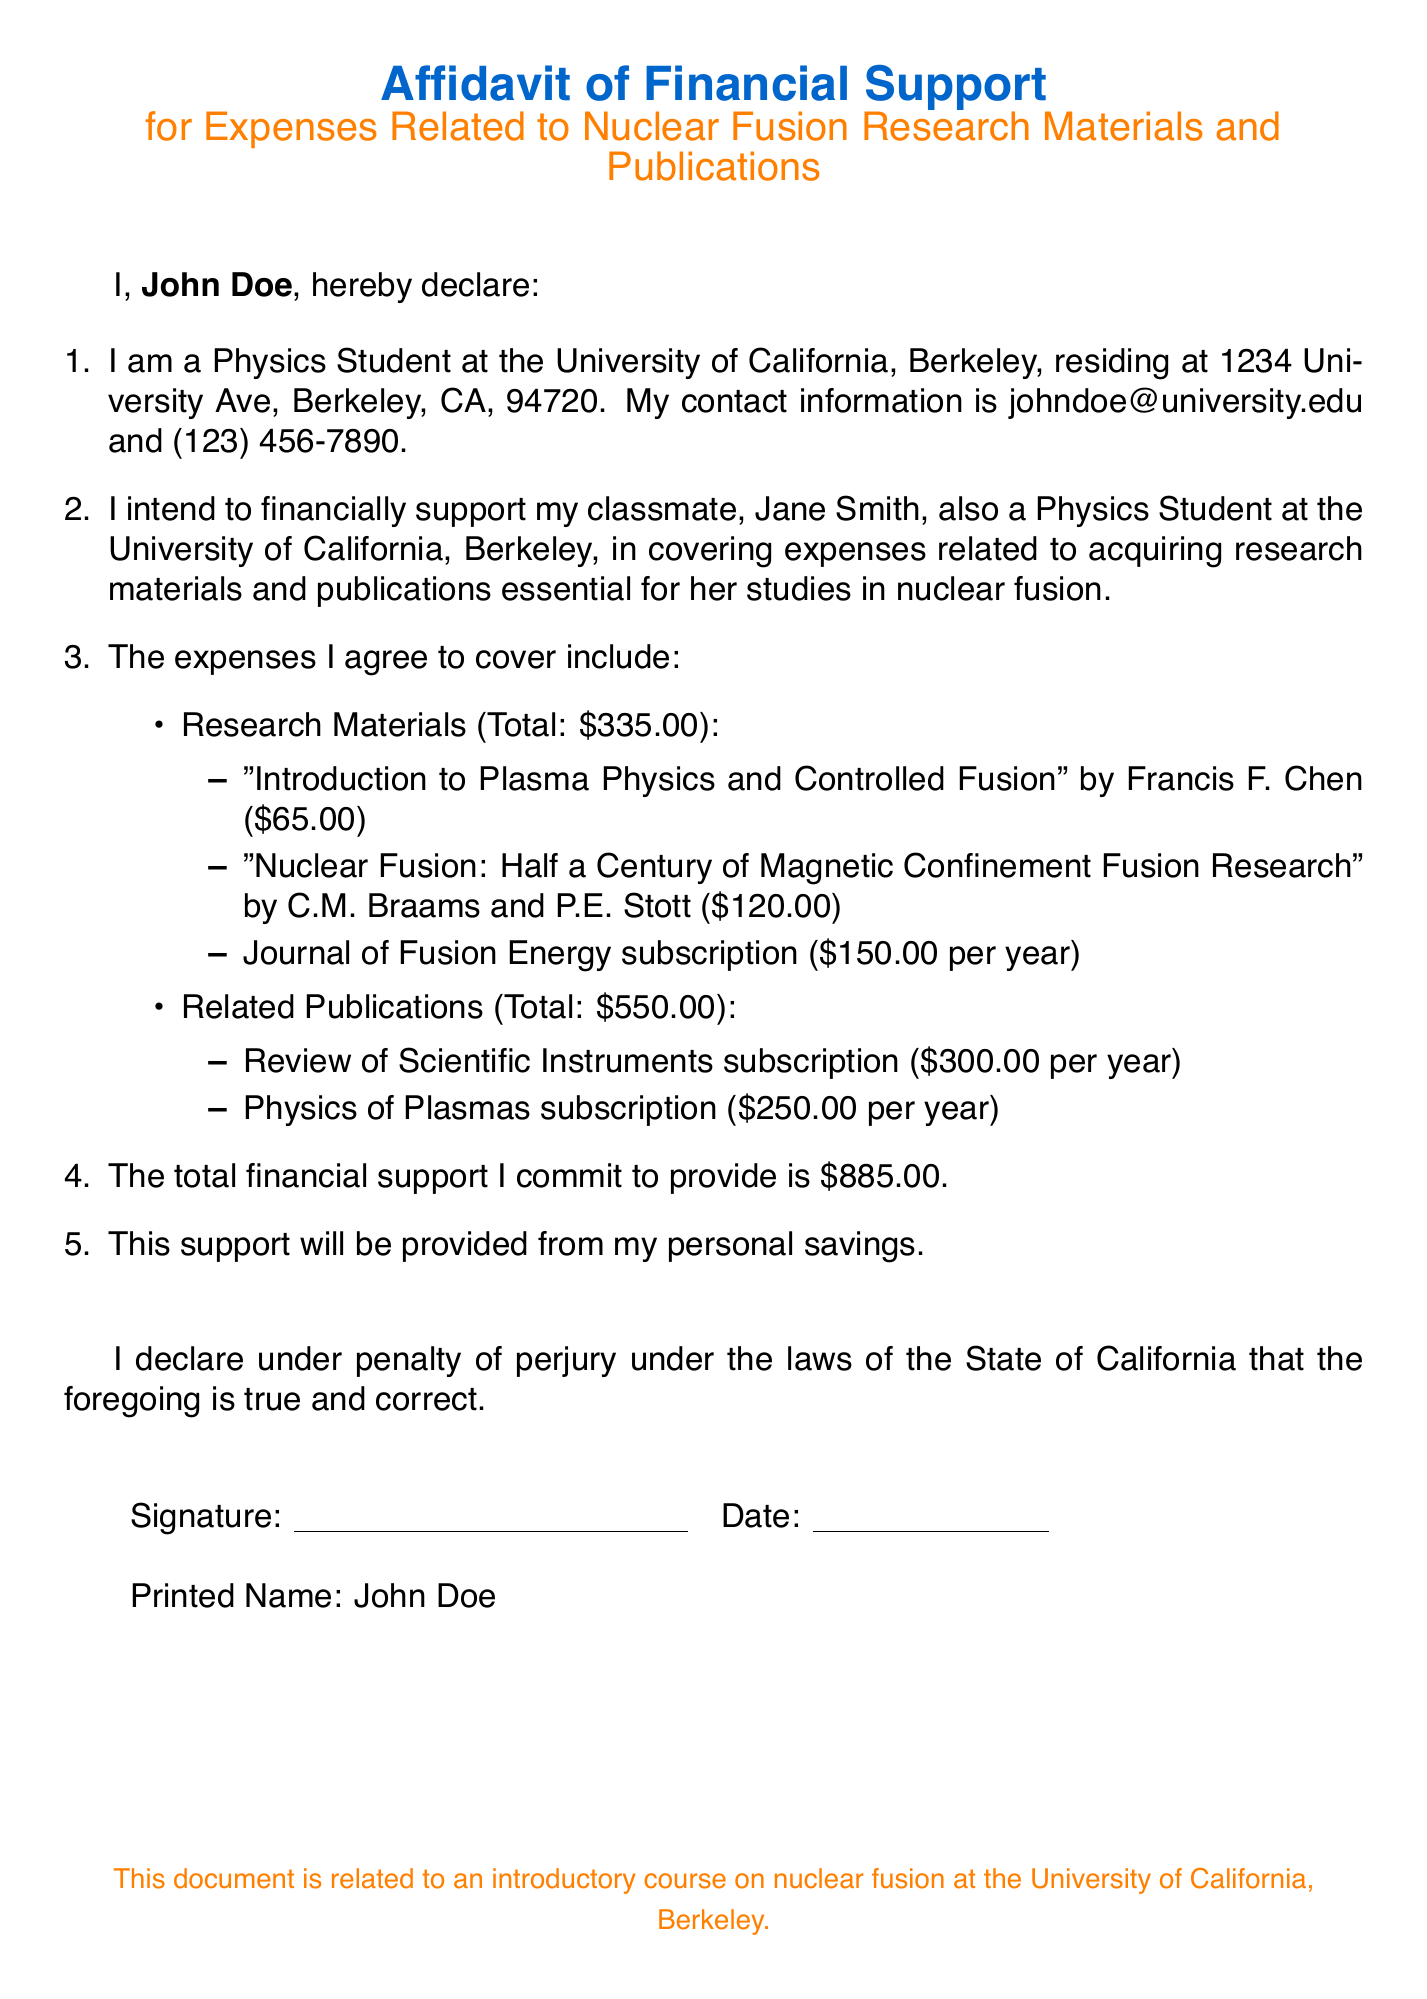What is the name of the affiant? The affiant is the person making the declaration in the affidavit, which is John Doe.
Answer: John Doe What is Jane Smith’s relationship to the affiant? Jane Smith is the classmate of the affiant, and the affiant intends to financially support her.
Answer: Classmate What is the total amount the affiant commits to provide? The total financial support can be found in the document, which specifies that the amount is eight hundred eighty-five dollars.
Answer: $885.00 How much does the subscription to the Journal of Fusion Energy cost? The document lists the cost of the Journal of Fusion Energy subscription as one hundred fifty dollars per year.
Answer: $150.00 From what sources will the financial support be provided? The document states that the support will be provided from the affiant's personal savings.
Answer: Personal savings What is the address of the affiant? The address is mentioned in the document as 1234 University Ave, Berkeley, CA, 94720.
Answer: 1234 University Ave, Berkeley, CA, 94720 What is the total cost for research materials? The total cost for research materials is specified in the document as three hundred thirty-five dollars.
Answer: $335.00 What type of document is this? It specifies in the header as an affidavit of financial support for research materials and publications.
Answer: Affidavit How many subscriptions are listed under related publications? The document lists two subscriptions under related publications.
Answer: Two 